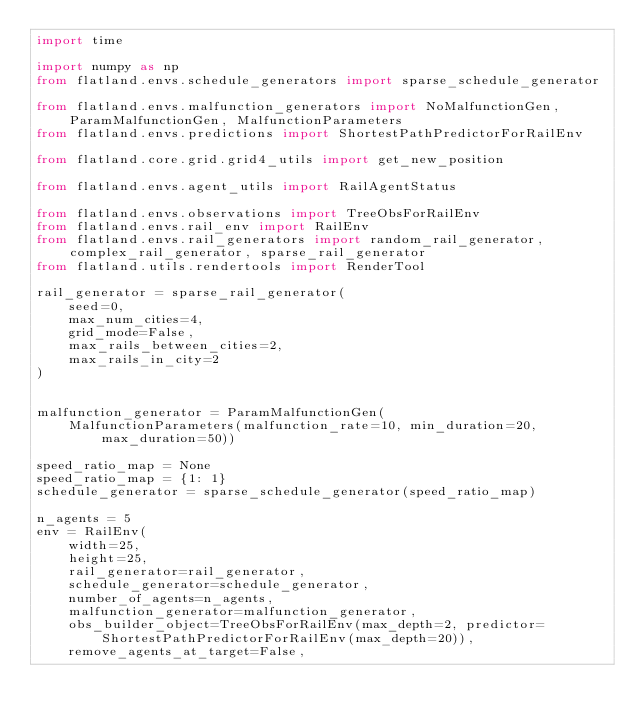<code> <loc_0><loc_0><loc_500><loc_500><_Python_>import time

import numpy as np
from flatland.envs.schedule_generators import sparse_schedule_generator

from flatland.envs.malfunction_generators import NoMalfunctionGen, ParamMalfunctionGen, MalfunctionParameters
from flatland.envs.predictions import ShortestPathPredictorForRailEnv

from flatland.core.grid.grid4_utils import get_new_position

from flatland.envs.agent_utils import RailAgentStatus

from flatland.envs.observations import TreeObsForRailEnv
from flatland.envs.rail_env import RailEnv
from flatland.envs.rail_generators import random_rail_generator, complex_rail_generator, sparse_rail_generator
from flatland.utils.rendertools import RenderTool

rail_generator = sparse_rail_generator(
    seed=0,
    max_num_cities=4,
    grid_mode=False,
    max_rails_between_cities=2,
    max_rails_in_city=2
)


malfunction_generator = ParamMalfunctionGen(
    MalfunctionParameters(malfunction_rate=10, min_duration=20, max_duration=50))

speed_ratio_map = None
speed_ratio_map = {1: 1}
schedule_generator = sparse_schedule_generator(speed_ratio_map)

n_agents = 5
env = RailEnv(
    width=25,
    height=25,
    rail_generator=rail_generator,
    schedule_generator=schedule_generator,
    number_of_agents=n_agents,
    malfunction_generator=malfunction_generator,
    obs_builder_object=TreeObsForRailEnv(max_depth=2, predictor=ShortestPathPredictorForRailEnv(max_depth=20)),
    remove_agents_at_target=False,</code> 